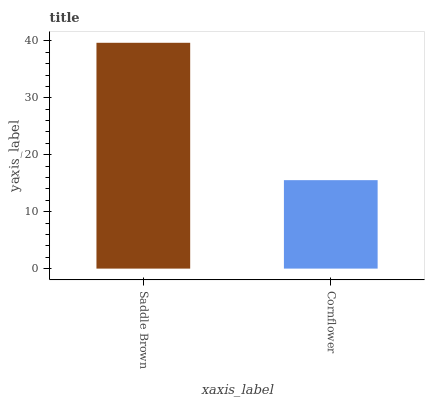Is Cornflower the minimum?
Answer yes or no. Yes. Is Saddle Brown the maximum?
Answer yes or no. Yes. Is Cornflower the maximum?
Answer yes or no. No. Is Saddle Brown greater than Cornflower?
Answer yes or no. Yes. Is Cornflower less than Saddle Brown?
Answer yes or no. Yes. Is Cornflower greater than Saddle Brown?
Answer yes or no. No. Is Saddle Brown less than Cornflower?
Answer yes or no. No. Is Saddle Brown the high median?
Answer yes or no. Yes. Is Cornflower the low median?
Answer yes or no. Yes. Is Cornflower the high median?
Answer yes or no. No. Is Saddle Brown the low median?
Answer yes or no. No. 